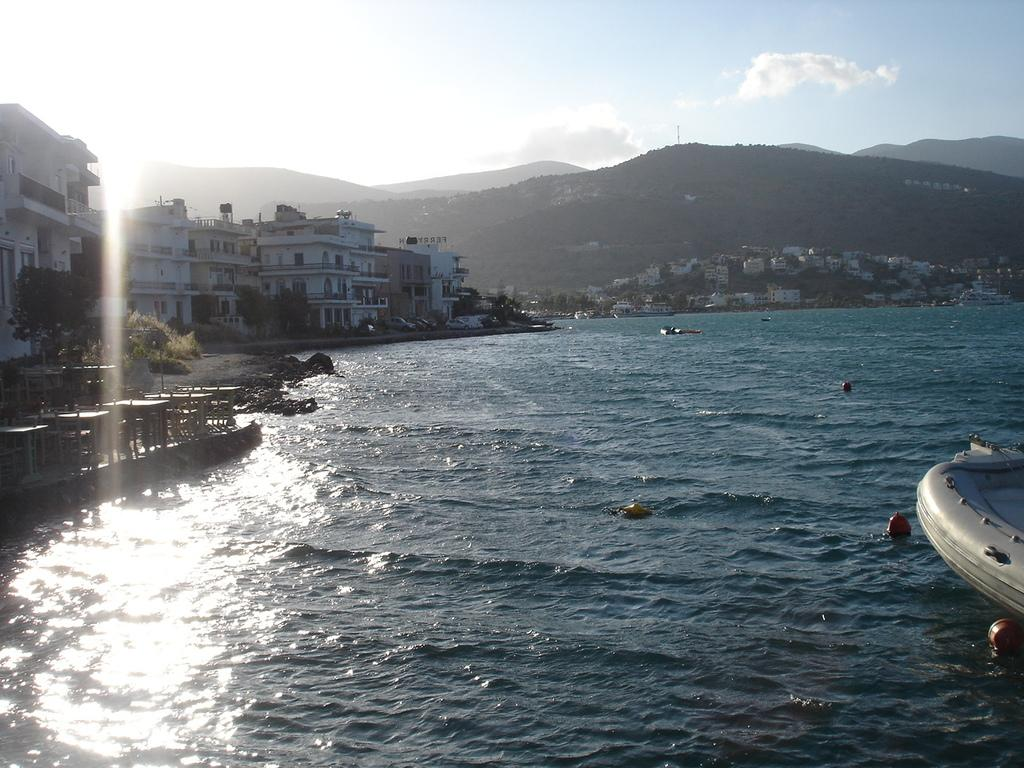What is the primary element visible in the image? There is water in the image. What can be seen on the right side of the image? There is a part of a boat on the right side of the image. What is located on the left side of the image? There are buildings and trees on the left side of the image. What is visible in the background of the image? There are hills, buildings, and the sky in the background of the image. What is the condition of the sky in the image? Clouds are present in the sky. What is the reason for the manager's decision to close the prison in the image? There is no prison or manager present in the image, so it is not possible to determine the reason for any decision. 